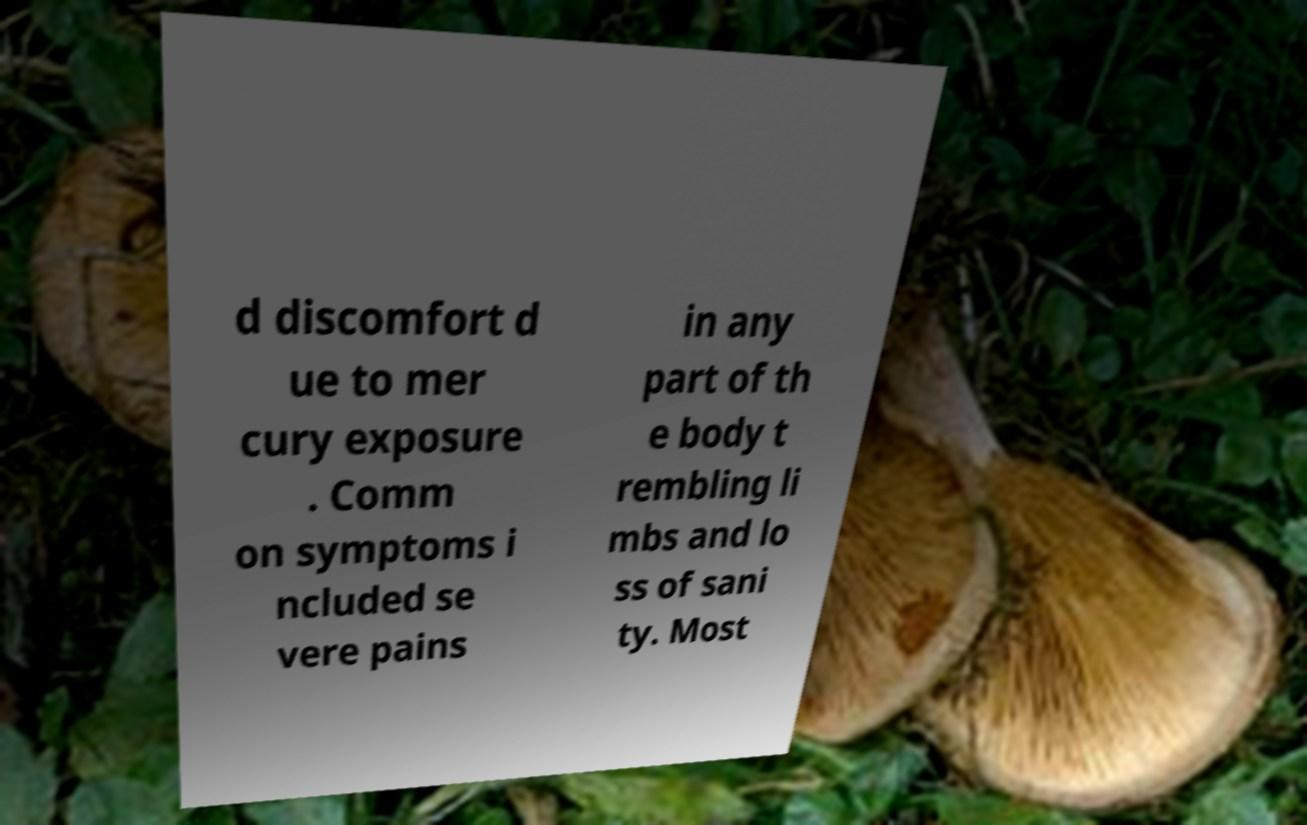Can you read and provide the text displayed in the image?This photo seems to have some interesting text. Can you extract and type it out for me? d discomfort d ue to mer cury exposure . Comm on symptoms i ncluded se vere pains in any part of th e body t rembling li mbs and lo ss of sani ty. Most 